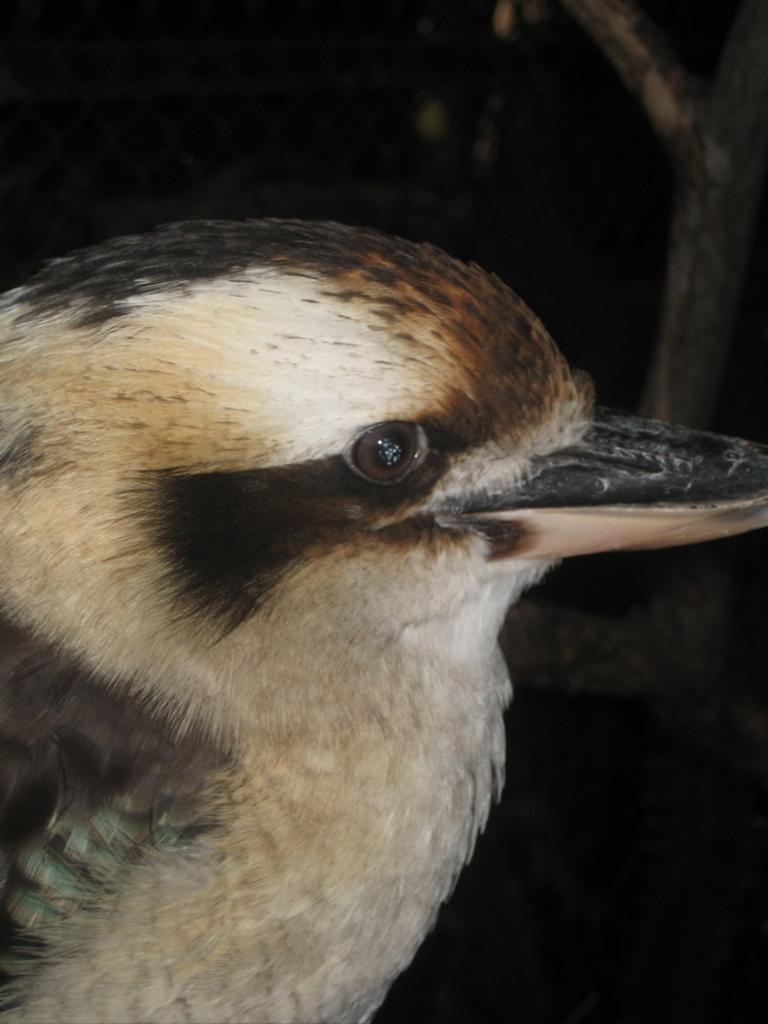In one or two sentences, can you explain what this image depicts? In this picture we can see a bird. Background portion of the picture is dark. 